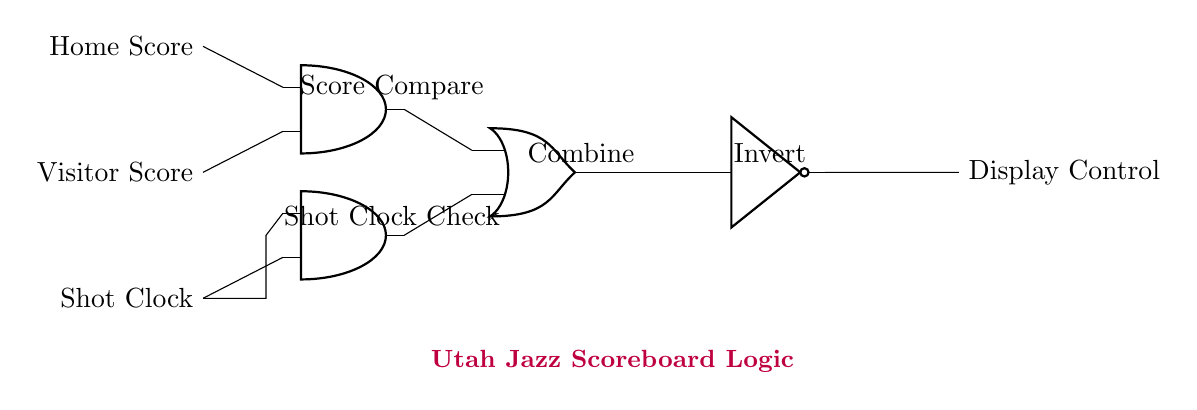What inputs are used in this logic gate circuit? The inputs are Home Score, Visitor Score, and Shot Clock, all of which are connected to different components in the circuit.
Answer: Home Score, Visitor Score, Shot Clock How many AND gates are present in the circuit? There are two AND gates in the circuit diagram, which are labeled as AND1 and AND2, indicating their functions in processing the inputs.
Answer: Two What does the OR gate in this circuit do? The OR gate combines the outputs from the two AND gates to produce a single output that is part of the logic controlling the scoreboard display.
Answer: Combine What is the purpose of the NOT gate in the circuit? The NOT gate inverts the output signal coming from the OR gate, creating a condition where the final display control can be turned off or on based on the previous logic.
Answer: Invert What are the two operations performed by the AND gates? AND1 performs a Score Compare operation while AND2 checks the Shot Clock, which is crucial for determining the scoreboard's output based on specific conditions.
Answer: Score Compare, Shot Clock Check Which gate provides the final output to Display Control? The final output to Display Control comes from the NOT gate, which inverts the output of the OR gate before sending the signal.
Answer: NOT gate 